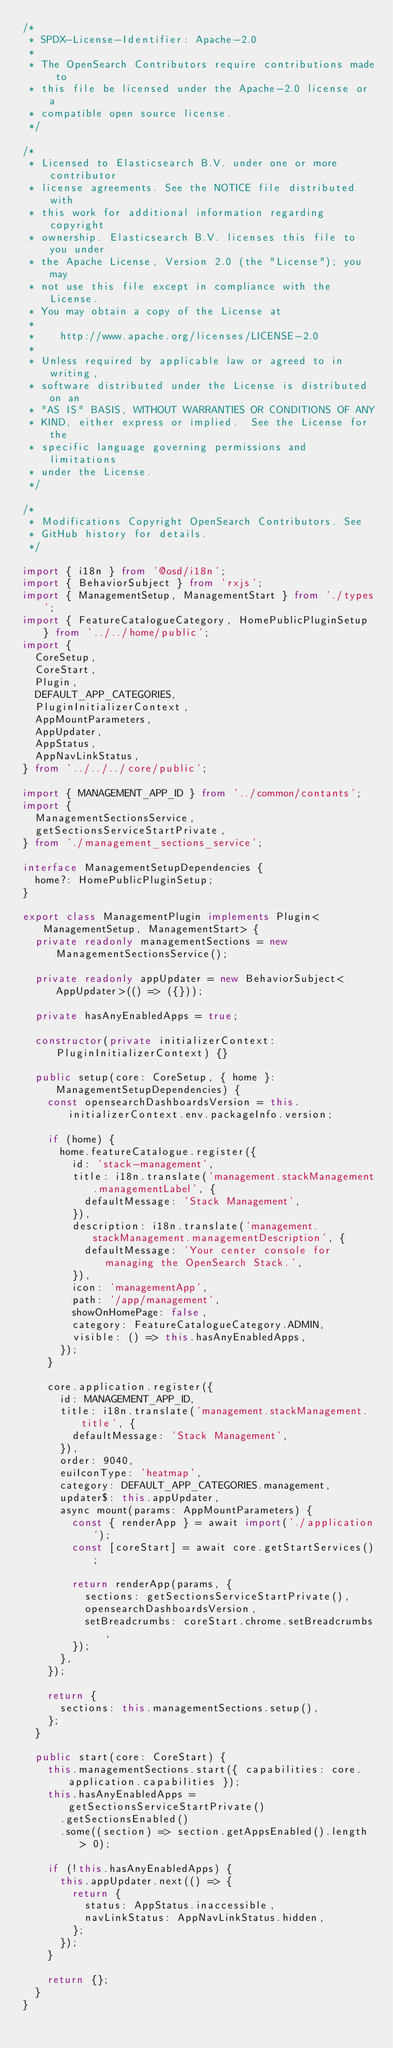<code> <loc_0><loc_0><loc_500><loc_500><_TypeScript_>/*
 * SPDX-License-Identifier: Apache-2.0
 *
 * The OpenSearch Contributors require contributions made to
 * this file be licensed under the Apache-2.0 license or a
 * compatible open source license.
 */

/*
 * Licensed to Elasticsearch B.V. under one or more contributor
 * license agreements. See the NOTICE file distributed with
 * this work for additional information regarding copyright
 * ownership. Elasticsearch B.V. licenses this file to you under
 * the Apache License, Version 2.0 (the "License"); you may
 * not use this file except in compliance with the License.
 * You may obtain a copy of the License at
 *
 *    http://www.apache.org/licenses/LICENSE-2.0
 *
 * Unless required by applicable law or agreed to in writing,
 * software distributed under the License is distributed on an
 * "AS IS" BASIS, WITHOUT WARRANTIES OR CONDITIONS OF ANY
 * KIND, either express or implied.  See the License for the
 * specific language governing permissions and limitations
 * under the License.
 */

/*
 * Modifications Copyright OpenSearch Contributors. See
 * GitHub history for details.
 */

import { i18n } from '@osd/i18n';
import { BehaviorSubject } from 'rxjs';
import { ManagementSetup, ManagementStart } from './types';
import { FeatureCatalogueCategory, HomePublicPluginSetup } from '../../home/public';
import {
  CoreSetup,
  CoreStart,
  Plugin,
  DEFAULT_APP_CATEGORIES,
  PluginInitializerContext,
  AppMountParameters,
  AppUpdater,
  AppStatus,
  AppNavLinkStatus,
} from '../../../core/public';

import { MANAGEMENT_APP_ID } from '../common/contants';
import {
  ManagementSectionsService,
  getSectionsServiceStartPrivate,
} from './management_sections_service';

interface ManagementSetupDependencies {
  home?: HomePublicPluginSetup;
}

export class ManagementPlugin implements Plugin<ManagementSetup, ManagementStart> {
  private readonly managementSections = new ManagementSectionsService();

  private readonly appUpdater = new BehaviorSubject<AppUpdater>(() => ({}));

  private hasAnyEnabledApps = true;

  constructor(private initializerContext: PluginInitializerContext) {}

  public setup(core: CoreSetup, { home }: ManagementSetupDependencies) {
    const opensearchDashboardsVersion = this.initializerContext.env.packageInfo.version;

    if (home) {
      home.featureCatalogue.register({
        id: 'stack-management',
        title: i18n.translate('management.stackManagement.managementLabel', {
          defaultMessage: 'Stack Management',
        }),
        description: i18n.translate('management.stackManagement.managementDescription', {
          defaultMessage: 'Your center console for managing the OpenSearch Stack.',
        }),
        icon: 'managementApp',
        path: '/app/management',
        showOnHomePage: false,
        category: FeatureCatalogueCategory.ADMIN,
        visible: () => this.hasAnyEnabledApps,
      });
    }

    core.application.register({
      id: MANAGEMENT_APP_ID,
      title: i18n.translate('management.stackManagement.title', {
        defaultMessage: 'Stack Management',
      }),
      order: 9040,
      euiIconType: 'heatmap',
      category: DEFAULT_APP_CATEGORIES.management,
      updater$: this.appUpdater,
      async mount(params: AppMountParameters) {
        const { renderApp } = await import('./application');
        const [coreStart] = await core.getStartServices();

        return renderApp(params, {
          sections: getSectionsServiceStartPrivate(),
          opensearchDashboardsVersion,
          setBreadcrumbs: coreStart.chrome.setBreadcrumbs,
        });
      },
    });

    return {
      sections: this.managementSections.setup(),
    };
  }

  public start(core: CoreStart) {
    this.managementSections.start({ capabilities: core.application.capabilities });
    this.hasAnyEnabledApps = getSectionsServiceStartPrivate()
      .getSectionsEnabled()
      .some((section) => section.getAppsEnabled().length > 0);

    if (!this.hasAnyEnabledApps) {
      this.appUpdater.next(() => {
        return {
          status: AppStatus.inaccessible,
          navLinkStatus: AppNavLinkStatus.hidden,
        };
      });
    }

    return {};
  }
}
</code> 